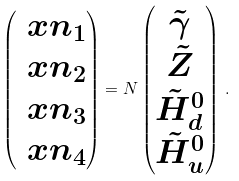Convert formula to latex. <formula><loc_0><loc_0><loc_500><loc_500>\begin{pmatrix} \ x n _ { 1 } \\ \ x n _ { 2 } \\ \ x n _ { 3 } \\ \ x n _ { 4 } \end{pmatrix} = { N } \begin{pmatrix} \tilde { \gamma } \\ \tilde { Z } \\ \tilde { H } _ { d } ^ { 0 } \\ \tilde { H } _ { u } ^ { 0 } \end{pmatrix} \, .</formula> 